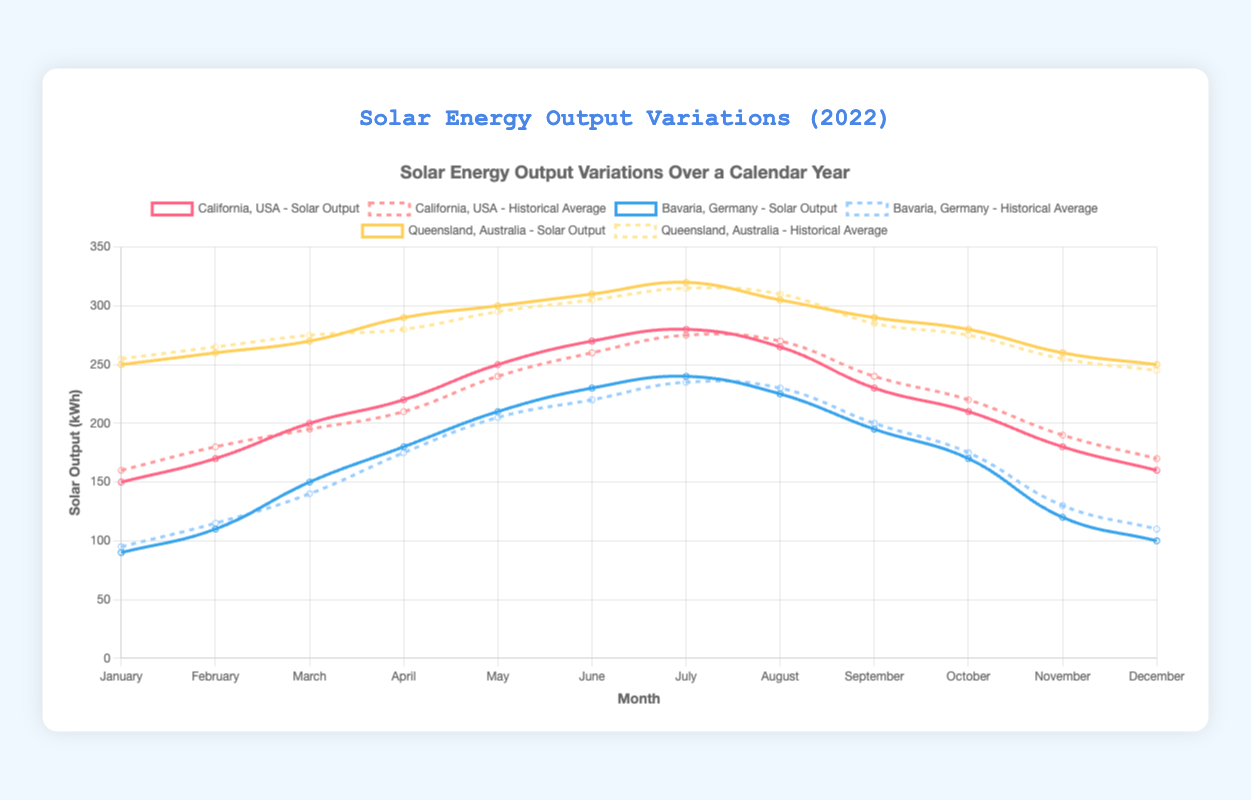Which location had the highest solar output in July 2022? Look at the graph and identify the lines representing July's solar output for California, Bavaria, and Queensland. Compare their heights to determine the highest output.
Answer: Queensland, Australia How does the solar output of California in September compare to its historical average? Find the September data points for both the 2022 output and the historical average for California. Then, compare the two values.
Answer: Lower What is the difference between the solar output of Queensland and Bavaria in May 2022? Find the May green line height for Queensland and blue line height for Bavaria. Subtract Bavaria's value from Queensland's value.
Answer: 90 kWh Which month had the smallest difference between solar output and historical average in Bavaria, Germany? For each month, calculate the absolute difference between the solar output and historical average values for Bavaria. Identify the month with the smallest difference.
Answer: April What's the average solar output for Queensland in the odd-numbered months? Sum the solar outputs for Queensland in January, March, May, July, September, and November, then divide by the number of these months.
Answer: 285 kWh Which months did California's solar output exceed its historical average in 2022? Compare the monthly solar output values with the historical averages. Identify months where California's solar output was higher.
Answer: March, April, May, June, July What is the sum of the solar outputs for February, March, and April in California? Add the solar output values for California in February, March, and April.
Answer: 590 kWh In which location does the highest monthly solar output occur? Compare the highest points on each line of the graph for the three locations. Identify the location with the highest peak value.
Answer: Queensland, Australia Are there any locations where the solar output never falls below the historical average? Examine each month's solar output and historical average for all three locations, verifying if any location always has the output higher than or equal to its historical average.
Answer: No 